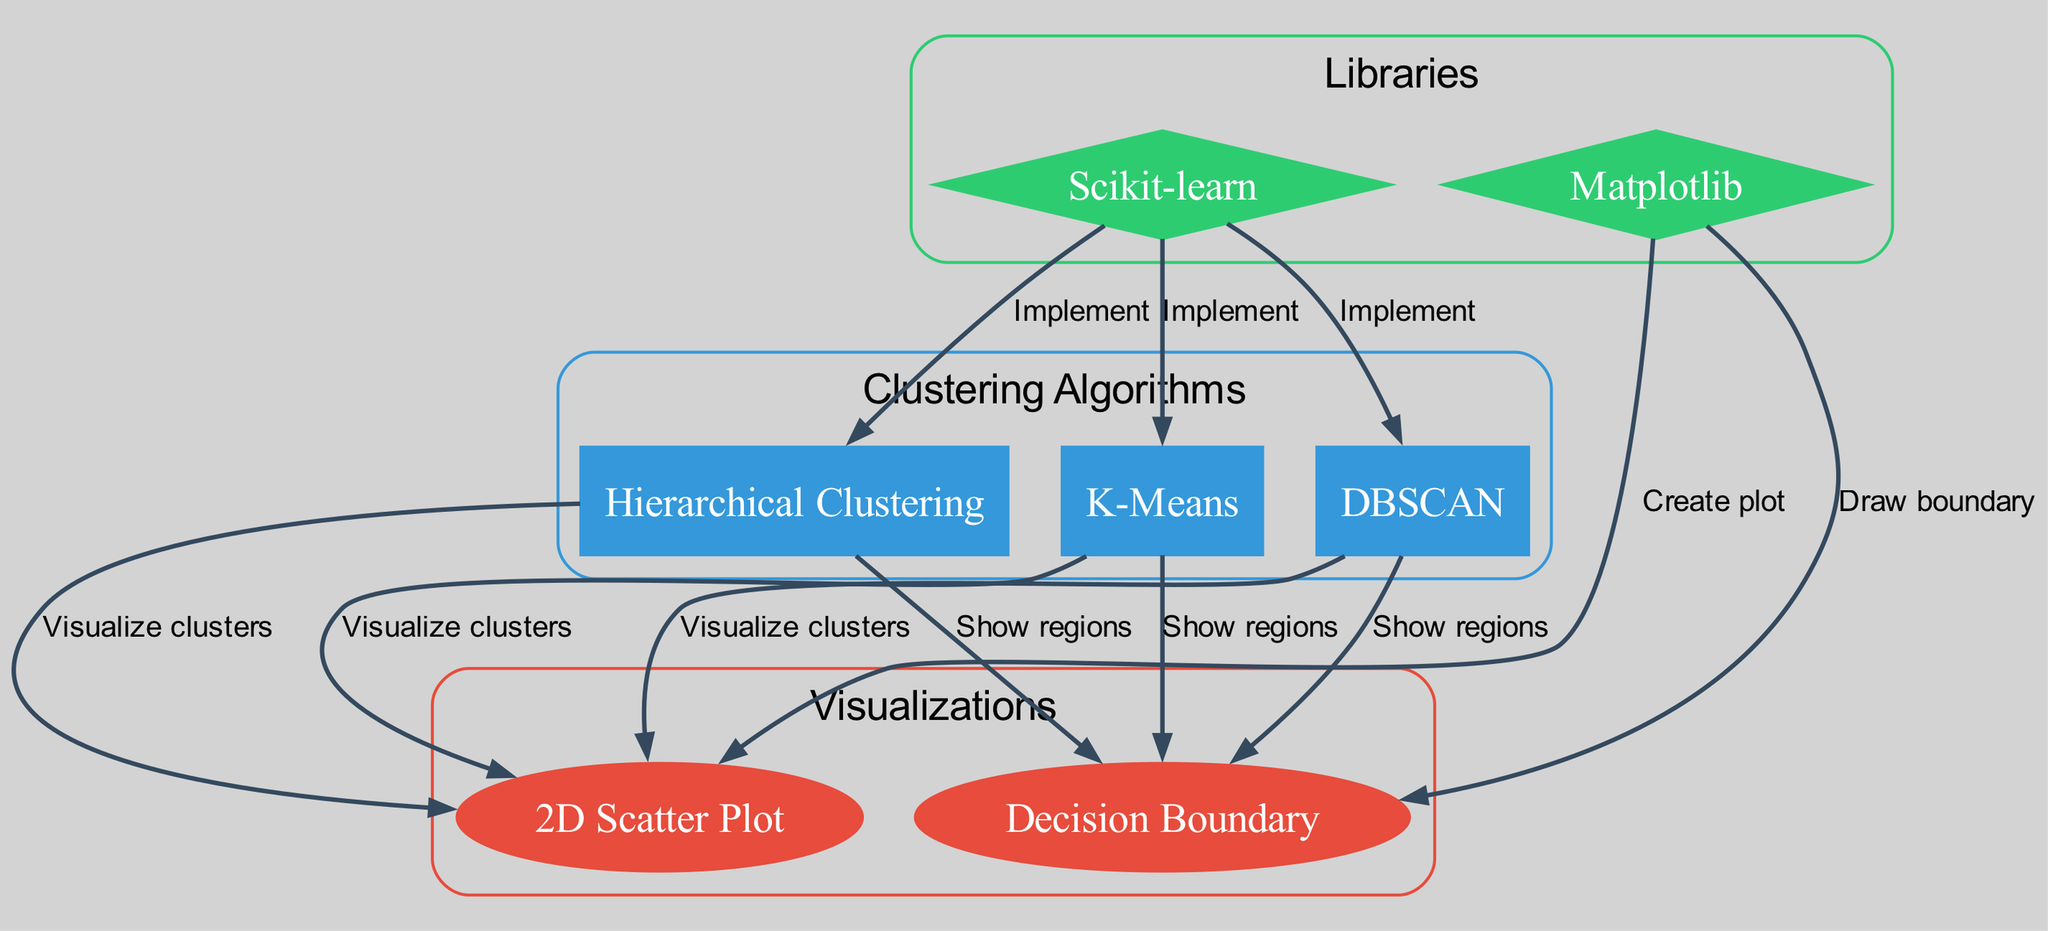What algorithms are represented in the diagram? The diagram includes three algorithms: K-Means, DBSCAN, and Hierarchical Clustering. Each algorithm is shown as a node type labeled "algorithm".
Answer: K-Means, DBSCAN, Hierarchical Clustering How many visualization nodes are there in the diagram? There are two visualization nodes in the diagram, which are "2D Scatter Plot" and "Decision Boundary". These are categorized as "visualization" type nodes.
Answer: 2 What library is used to implement the clustering algorithms? The diagram indicates that the Scikit-learn library is used for implementing all three clustering algorithms, represented by a node labeled "Scikit-learn".
Answer: Scikit-learn Which visualization node is connected to K-Means? The "2D Scatter Plot" node is connected to K-Means, indicating that the clusters formed by K-Means can be visualized using this plot. It is labeled as "Visualize clusters".
Answer: 2D Scatter Plot What does the edge between DBSCAN and the "Decision Boundary" node represent? The edge signifies that the DBSCAN algorithm shows regions of clusters through the "Decision Boundary", which is used to visualize how the algorithm partitions the space.
Answer: Show regions How many edges are connected to the "2D Scatter Plot" node? The "2D Scatter Plot" node has three edges connected to it; one each from K-Means, DBSCAN, and Hierarchical Clustering. Each edge is labeled as "Visualize clusters".
Answer: 3 Which visualization is specifically associated with the library Matplotlib? The "2D Scatter Plot" and "Decision Boundary" nodes are specifically associated with the library Matplotlib. The edges indicate that Matplotlib creates the plot and draws the corresponding boundaries.
Answer: 2 Which algorithm does not require specifying the number of clusters? DBSCAN does not require specifying the number of clusters as it identifies clusters based on density rather than a preset number of clusters.
Answer: DBSCAN What type of boundary is shown for K-Means in the diagram? The diagram shows a "Decision Boundary" for K-Means, indicating how the algorithm partitions the space into different regions corresponding to different clusters.
Answer: Decision Boundary 